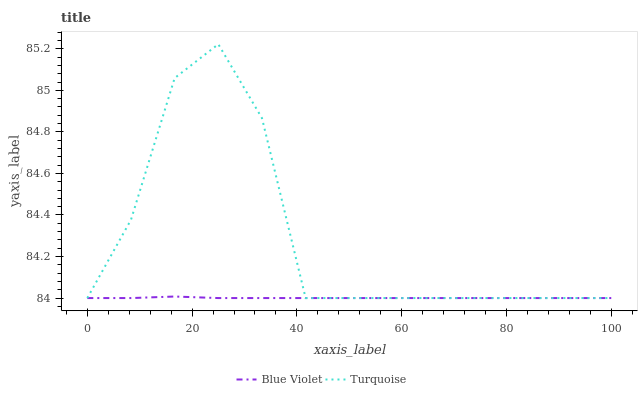Does Blue Violet have the minimum area under the curve?
Answer yes or no. Yes. Does Turquoise have the maximum area under the curve?
Answer yes or no. Yes. Does Blue Violet have the maximum area under the curve?
Answer yes or no. No. Is Blue Violet the smoothest?
Answer yes or no. Yes. Is Turquoise the roughest?
Answer yes or no. Yes. Is Blue Violet the roughest?
Answer yes or no. No. Does Turquoise have the lowest value?
Answer yes or no. Yes. Does Turquoise have the highest value?
Answer yes or no. Yes. Does Blue Violet have the highest value?
Answer yes or no. No. Does Turquoise intersect Blue Violet?
Answer yes or no. Yes. Is Turquoise less than Blue Violet?
Answer yes or no. No. Is Turquoise greater than Blue Violet?
Answer yes or no. No. 